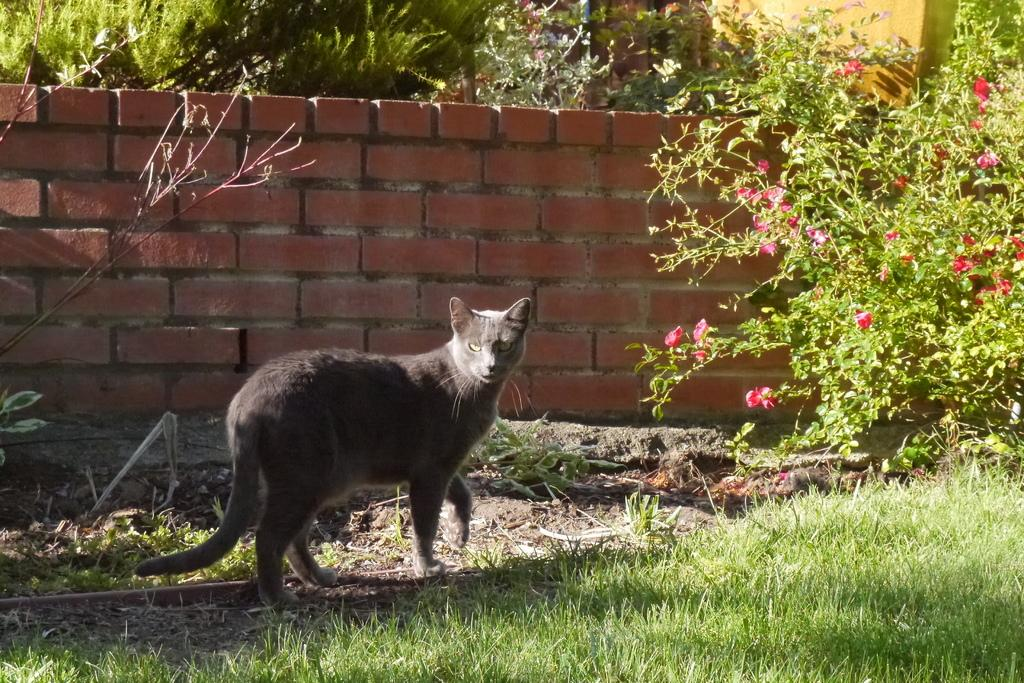What is the main subject in the center of the image? There is an animal in the center of the image. What can be seen in the background of the image? There is a wall, plants, and flowers in the background of the image. What type of vegetation is present at the bottom of the image? There is grass at the bottom of the image. What is the purpose of the linen in the image? There is no linen present in the image. 